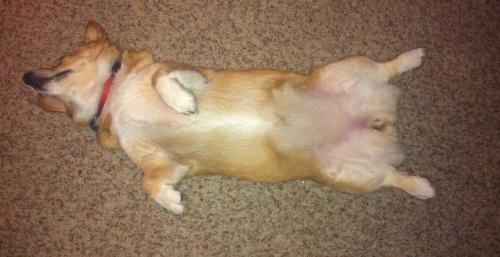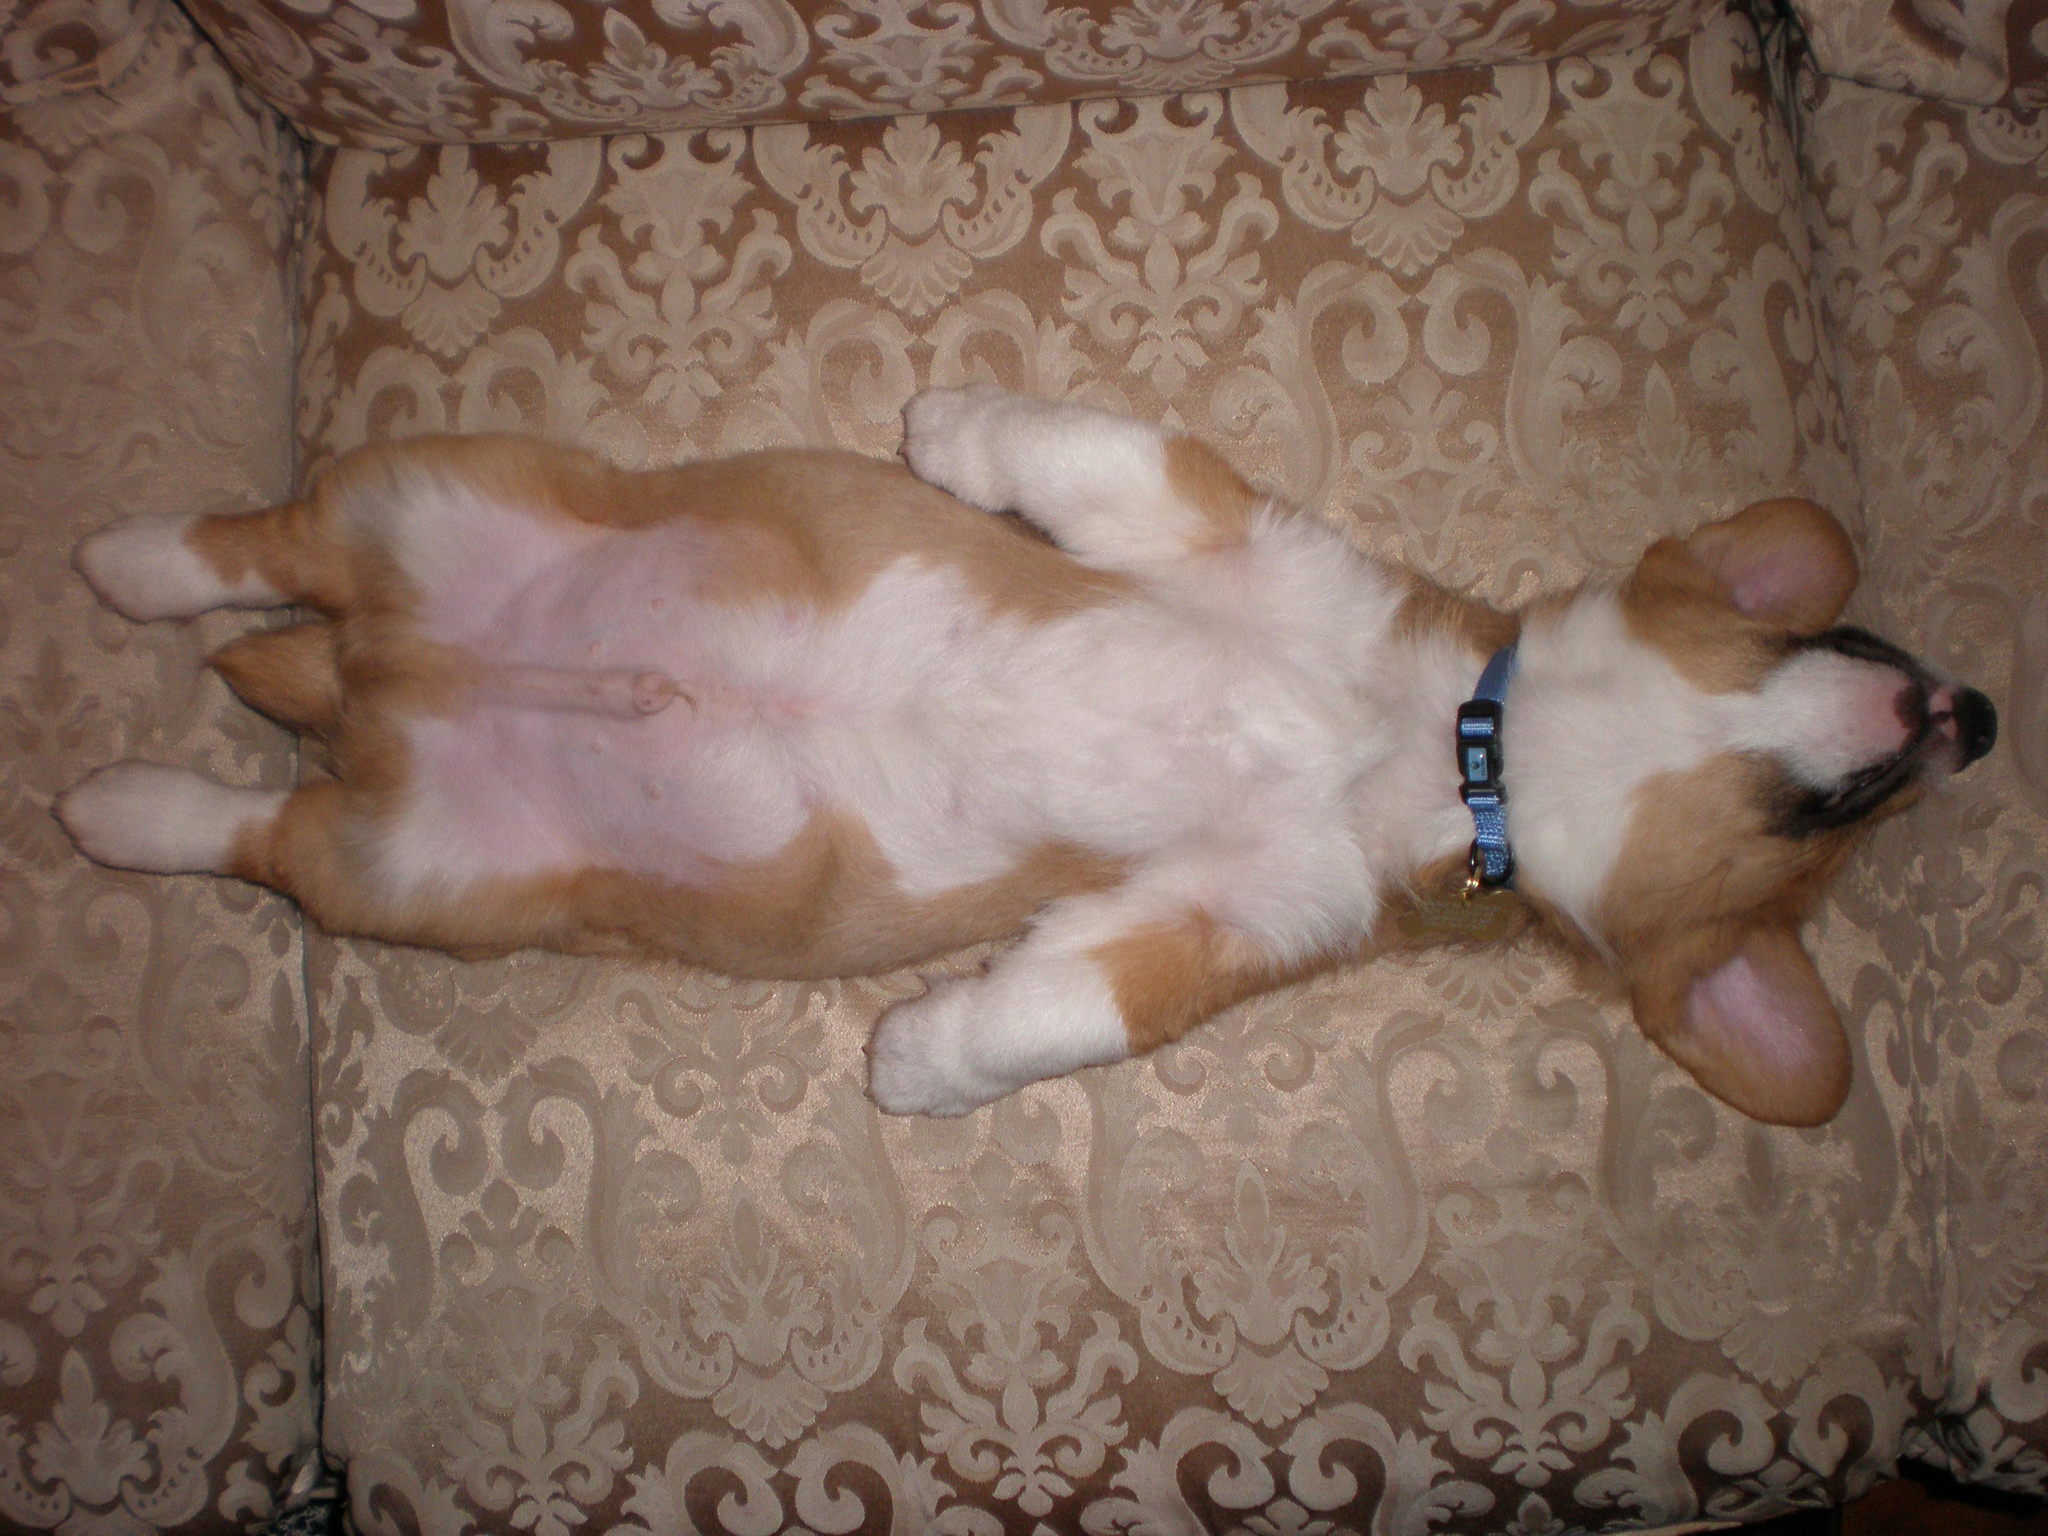The first image is the image on the left, the second image is the image on the right. Examine the images to the left and right. Is the description "Both dogs are sleeping on their backs." accurate? Answer yes or no. Yes. The first image is the image on the left, the second image is the image on the right. Analyze the images presented: Is the assertion "Each image shows one orange-and-white corgi dog, each image shows a dog lying on its back, and one dog is wearing a bluish collar." valid? Answer yes or no. Yes. 